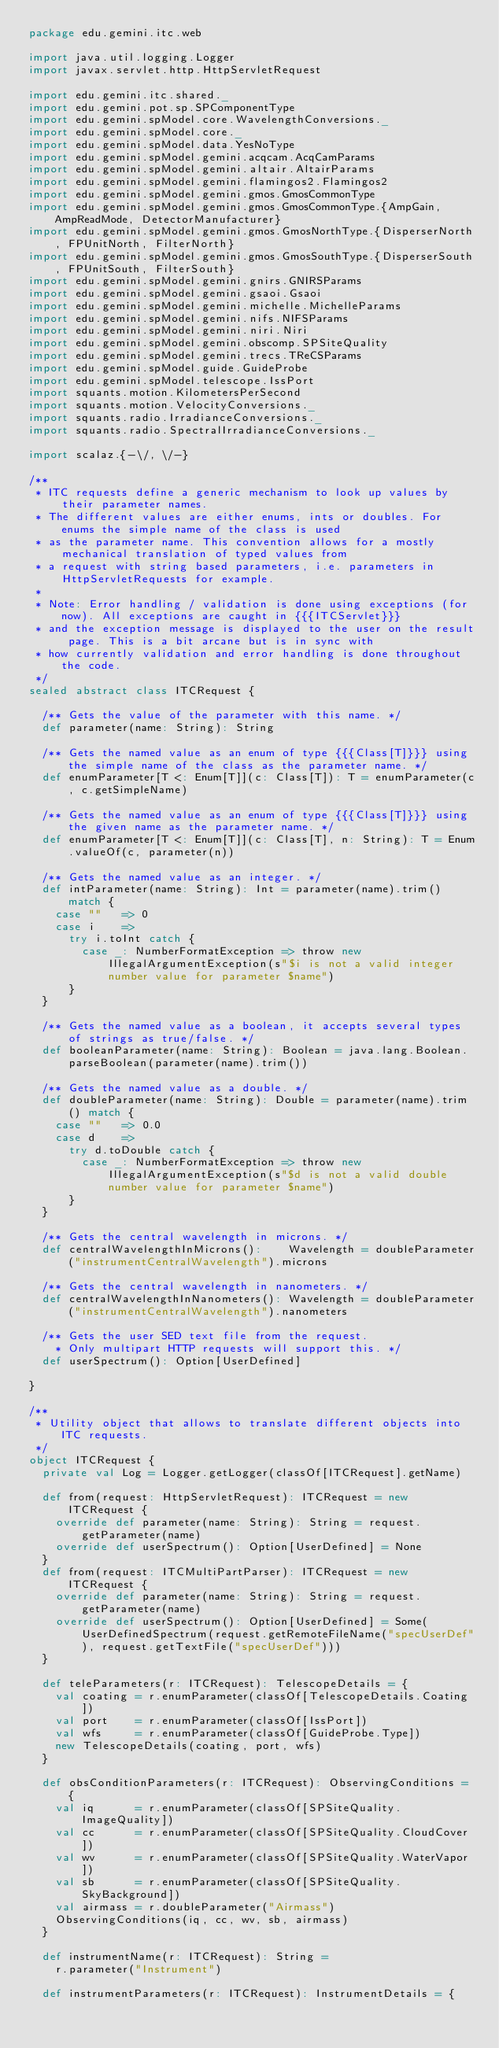Convert code to text. <code><loc_0><loc_0><loc_500><loc_500><_Scala_>package edu.gemini.itc.web

import java.util.logging.Logger
import javax.servlet.http.HttpServletRequest

import edu.gemini.itc.shared._
import edu.gemini.pot.sp.SPComponentType
import edu.gemini.spModel.core.WavelengthConversions._
import edu.gemini.spModel.core._
import edu.gemini.spModel.data.YesNoType
import edu.gemini.spModel.gemini.acqcam.AcqCamParams
import edu.gemini.spModel.gemini.altair.AltairParams
import edu.gemini.spModel.gemini.flamingos2.Flamingos2
import edu.gemini.spModel.gemini.gmos.GmosCommonType
import edu.gemini.spModel.gemini.gmos.GmosCommonType.{AmpGain, AmpReadMode, DetectorManufacturer}
import edu.gemini.spModel.gemini.gmos.GmosNorthType.{DisperserNorth, FPUnitNorth, FilterNorth}
import edu.gemini.spModel.gemini.gmos.GmosSouthType.{DisperserSouth, FPUnitSouth, FilterSouth}
import edu.gemini.spModel.gemini.gnirs.GNIRSParams
import edu.gemini.spModel.gemini.gsaoi.Gsaoi
import edu.gemini.spModel.gemini.michelle.MichelleParams
import edu.gemini.spModel.gemini.nifs.NIFSParams
import edu.gemini.spModel.gemini.niri.Niri
import edu.gemini.spModel.gemini.obscomp.SPSiteQuality
import edu.gemini.spModel.gemini.trecs.TReCSParams
import edu.gemini.spModel.guide.GuideProbe
import edu.gemini.spModel.telescope.IssPort
import squants.motion.KilometersPerSecond
import squants.motion.VelocityConversions._
import squants.radio.IrradianceConversions._
import squants.radio.SpectralIrradianceConversions._

import scalaz.{-\/, \/-}

/**
 * ITC requests define a generic mechanism to look up values by their parameter names.
 * The different values are either enums, ints or doubles. For enums the simple name of the class is used
 * as the parameter name. This convention allows for a mostly mechanical translation of typed values from
 * a request with string based parameters, i.e. parameters in HttpServletRequests for example.
 *
 * Note: Error handling / validation is done using exceptions (for now). All exceptions are caught in {{{ITCServlet}}}
 * and the exception message is displayed to the user on the result page. This is a bit arcane but is in sync with
 * how currently validation and error handling is done throughout the code.
 */
sealed abstract class ITCRequest {

  /** Gets the value of the parameter with this name. */
  def parameter(name: String): String

  /** Gets the named value as an enum of type {{{Class[T]}}} using the simple name of the class as the parameter name. */
  def enumParameter[T <: Enum[T]](c: Class[T]): T = enumParameter(c, c.getSimpleName)

  /** Gets the named value as an enum of type {{{Class[T]}}} using the given name as the parameter name. */
  def enumParameter[T <: Enum[T]](c: Class[T], n: String): T = Enum.valueOf(c, parameter(n))

  /** Gets the named value as an integer. */
  def intParameter(name: String): Int = parameter(name).trim() match {
    case ""   => 0
    case i    =>
      try i.toInt catch {
        case _: NumberFormatException => throw new IllegalArgumentException(s"$i is not a valid integer number value for parameter $name")
      }
  }

  /** Gets the named value as a boolean, it accepts several types of strings as true/false. */
  def booleanParameter(name: String): Boolean = java.lang.Boolean.parseBoolean(parameter(name).trim())

  /** Gets the named value as a double. */
  def doubleParameter(name: String): Double = parameter(name).trim() match {
    case ""   => 0.0
    case d    =>
      try d.toDouble catch {
        case _: NumberFormatException => throw new IllegalArgumentException(s"$d is not a valid double number value for parameter $name")
      }
  }

  /** Gets the central wavelength in microns. */
  def centralWavelengthInMicrons():    Wavelength = doubleParameter("instrumentCentralWavelength").microns

  /** Gets the central wavelength in nanometers. */
  def centralWavelengthInNanometers(): Wavelength = doubleParameter("instrumentCentralWavelength").nanometers

  /** Gets the user SED text file from the request.
    * Only multipart HTTP requests will support this. */
  def userSpectrum(): Option[UserDefined]

}

/**
 * Utility object that allows to translate different objects into ITC requests.
 */
object ITCRequest {
  private val Log = Logger.getLogger(classOf[ITCRequest].getName)

  def from(request: HttpServletRequest): ITCRequest = new ITCRequest {
    override def parameter(name: String): String = request.getParameter(name)
    override def userSpectrum(): Option[UserDefined] = None
  }
  def from(request: ITCMultiPartParser): ITCRequest = new ITCRequest {
    override def parameter(name: String): String = request.getParameter(name)
    override def userSpectrum(): Option[UserDefined] = Some(UserDefinedSpectrum(request.getRemoteFileName("specUserDef"), request.getTextFile("specUserDef")))
  }

  def teleParameters(r: ITCRequest): TelescopeDetails = {
    val coating = r.enumParameter(classOf[TelescopeDetails.Coating])
    val port    = r.enumParameter(classOf[IssPort])
    val wfs     = r.enumParameter(classOf[GuideProbe.Type])
    new TelescopeDetails(coating, port, wfs)
  }

  def obsConditionParameters(r: ITCRequest): ObservingConditions = {
    val iq      = r.enumParameter(classOf[SPSiteQuality.ImageQuality])
    val cc      = r.enumParameter(classOf[SPSiteQuality.CloudCover])
    val wv      = r.enumParameter(classOf[SPSiteQuality.WaterVapor])
    val sb      = r.enumParameter(classOf[SPSiteQuality.SkyBackground])
    val airmass = r.doubleParameter("Airmass")
    ObservingConditions(iq, cc, wv, sb, airmass)
  }

  def instrumentName(r: ITCRequest): String =
    r.parameter("Instrument")

  def instrumentParameters(r: ITCRequest): InstrumentDetails = {</code> 